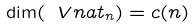Convert formula to latex. <formula><loc_0><loc_0><loc_500><loc_500>\dim ( \ V n a t _ { n } ) = c ( n )</formula> 